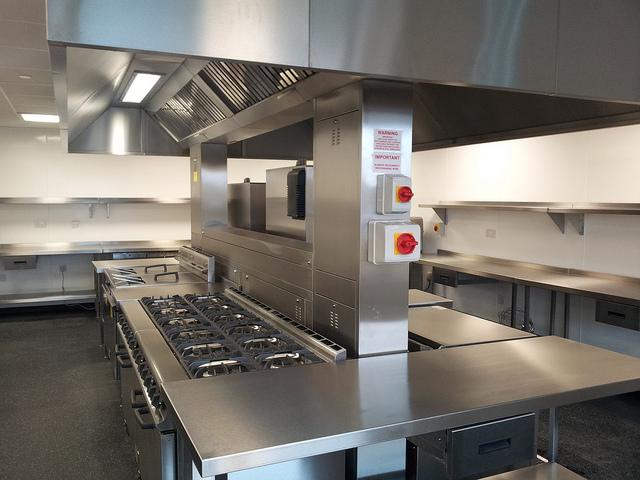Is this kitchen open?
Be succinct. No. Is food being prepared?
Keep it brief. No. Are the counters made of wood?
Be succinct. No. 